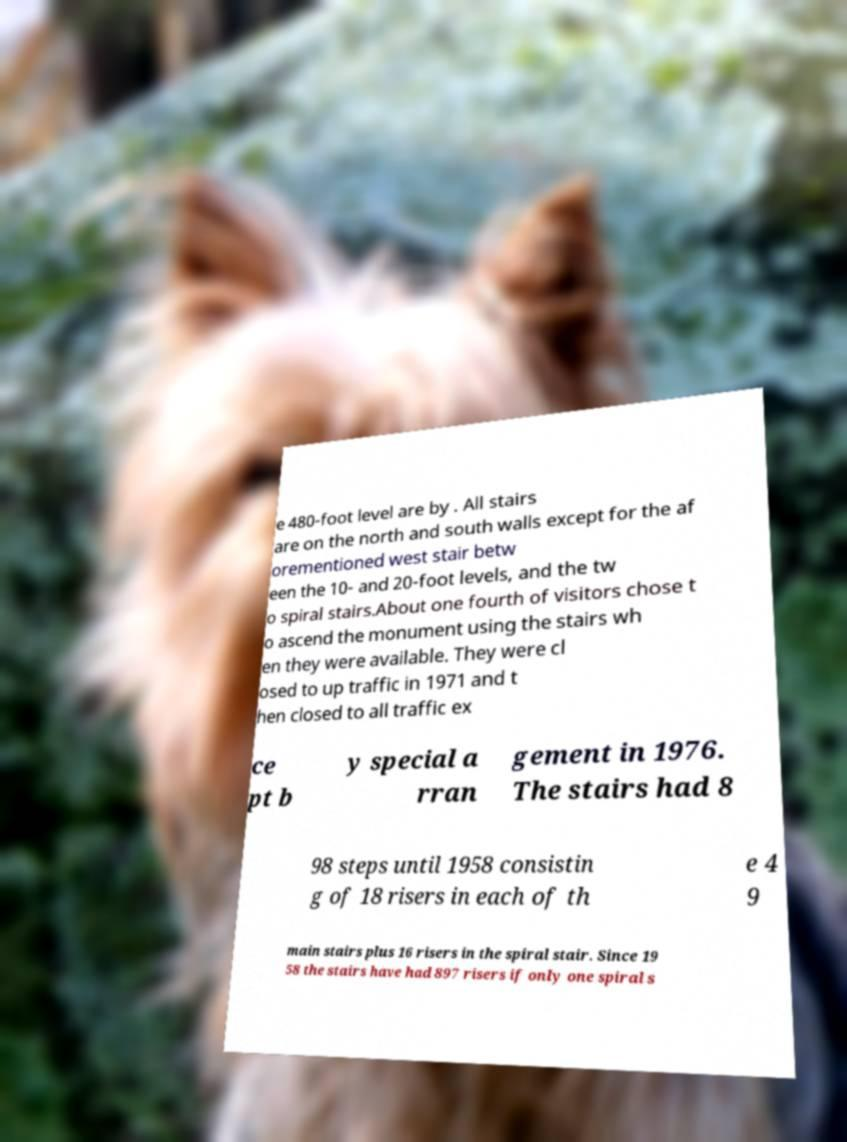What messages or text are displayed in this image? I need them in a readable, typed format. e 480-foot level are by . All stairs are on the north and south walls except for the af orementioned west stair betw een the 10- and 20-foot levels, and the tw o spiral stairs.About one fourth of visitors chose t o ascend the monument using the stairs wh en they were available. They were cl osed to up traffic in 1971 and t hen closed to all traffic ex ce pt b y special a rran gement in 1976. The stairs had 8 98 steps until 1958 consistin g of 18 risers in each of th e 4 9 main stairs plus 16 risers in the spiral stair. Since 19 58 the stairs have had 897 risers if only one spiral s 